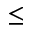Convert formula to latex. <formula><loc_0><loc_0><loc_500><loc_500>\leq</formula> 